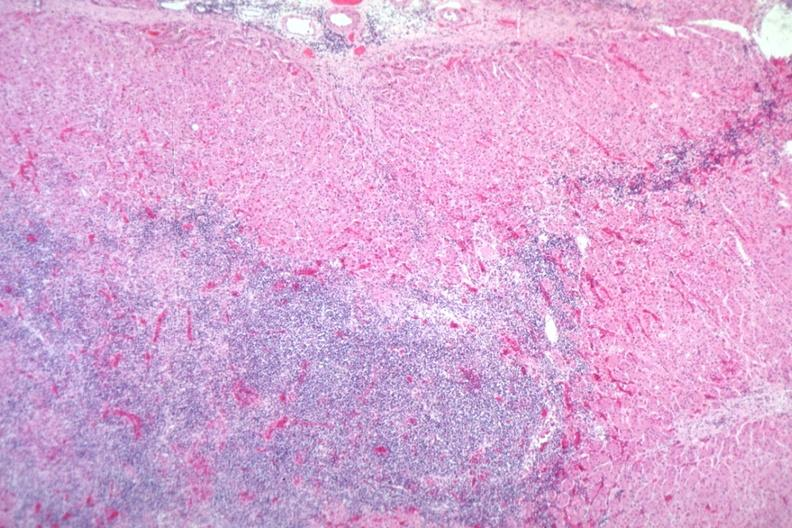what is present?
Answer the question using a single word or phrase. Endocrine 